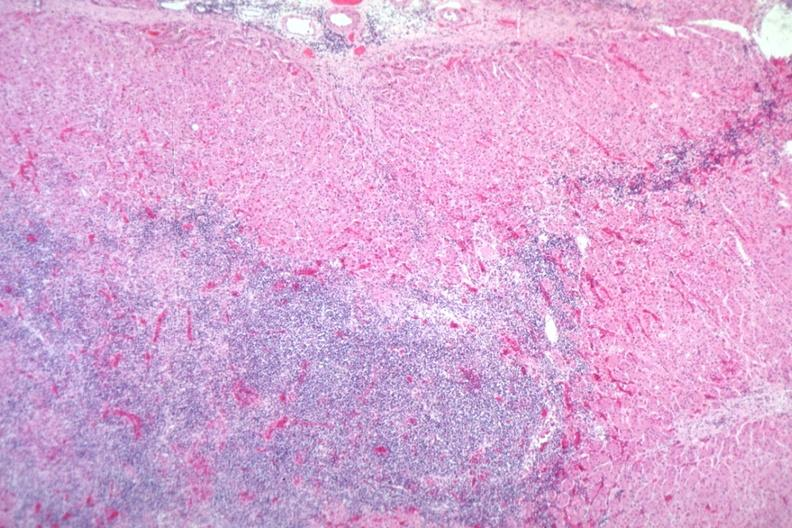what is present?
Answer the question using a single word or phrase. Endocrine 